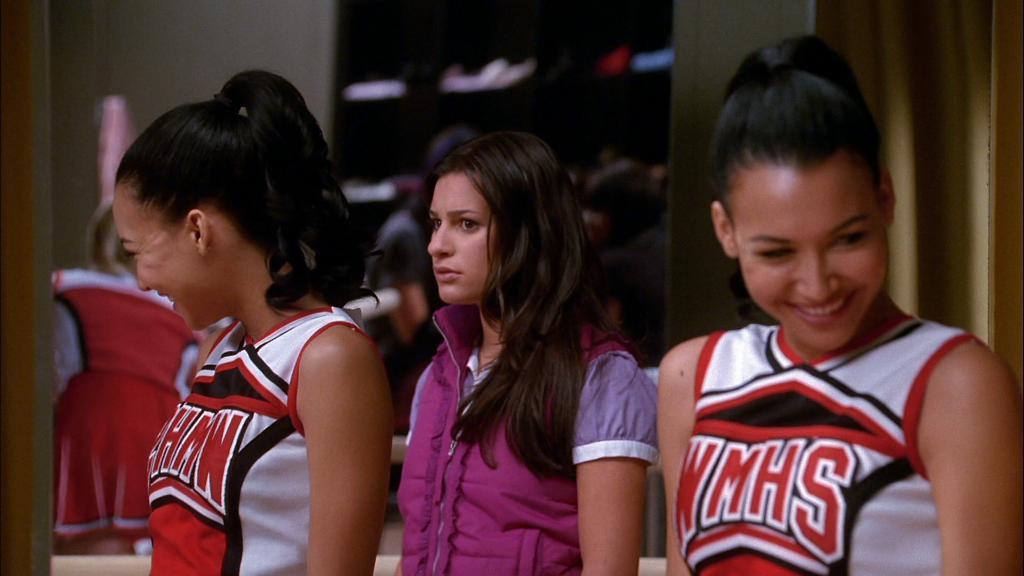Is this cheerleader in middle school or high school?
Provide a succinct answer. High school. 